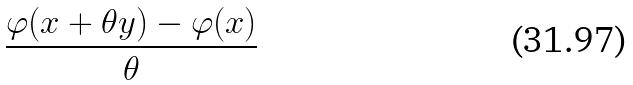Convert formula to latex. <formula><loc_0><loc_0><loc_500><loc_500>\frac { \varphi ( x + \theta y ) - \varphi ( x ) } { \theta }</formula> 